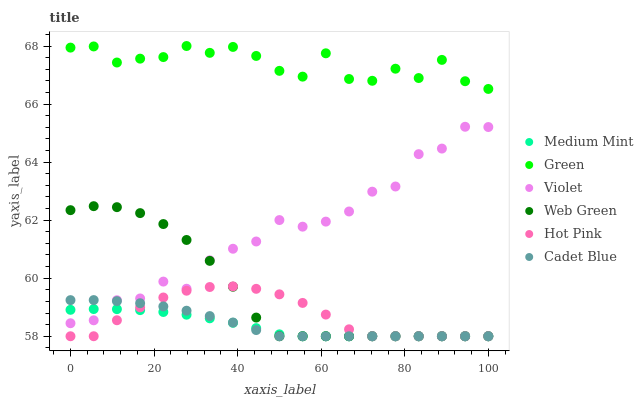Does Medium Mint have the minimum area under the curve?
Answer yes or no. Yes. Does Green have the maximum area under the curve?
Answer yes or no. Yes. Does Cadet Blue have the minimum area under the curve?
Answer yes or no. No. Does Cadet Blue have the maximum area under the curve?
Answer yes or no. No. Is Medium Mint the smoothest?
Answer yes or no. Yes. Is Green the roughest?
Answer yes or no. Yes. Is Cadet Blue the smoothest?
Answer yes or no. No. Is Cadet Blue the roughest?
Answer yes or no. No. Does Medium Mint have the lowest value?
Answer yes or no. Yes. Does Green have the lowest value?
Answer yes or no. No. Does Green have the highest value?
Answer yes or no. Yes. Does Cadet Blue have the highest value?
Answer yes or no. No. Is Violet less than Green?
Answer yes or no. Yes. Is Green greater than Violet?
Answer yes or no. Yes. Does Web Green intersect Cadet Blue?
Answer yes or no. Yes. Is Web Green less than Cadet Blue?
Answer yes or no. No. Is Web Green greater than Cadet Blue?
Answer yes or no. No. Does Violet intersect Green?
Answer yes or no. No. 